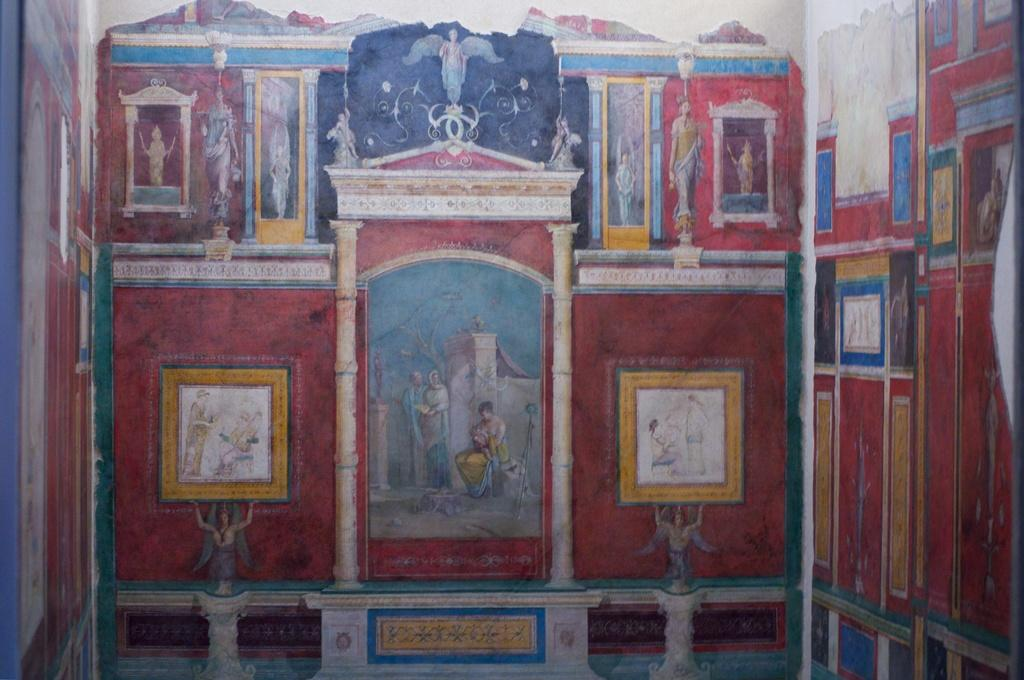What is present on the wall in the image? There is a painting on the wall in the image. What subjects are depicted in the painting? The painting contains people, buildings, statues, and trees. What type of artwork is the painting? The painting is a scene that includes various subjects. What type of quill can be seen in the painting? There is no quill present in the painting; it contains people, buildings, statues, and trees. What type of flesh is visible on the statues in the painting? There is no flesh visible on the statues in the painting, as they are likely made of stone or another material. 